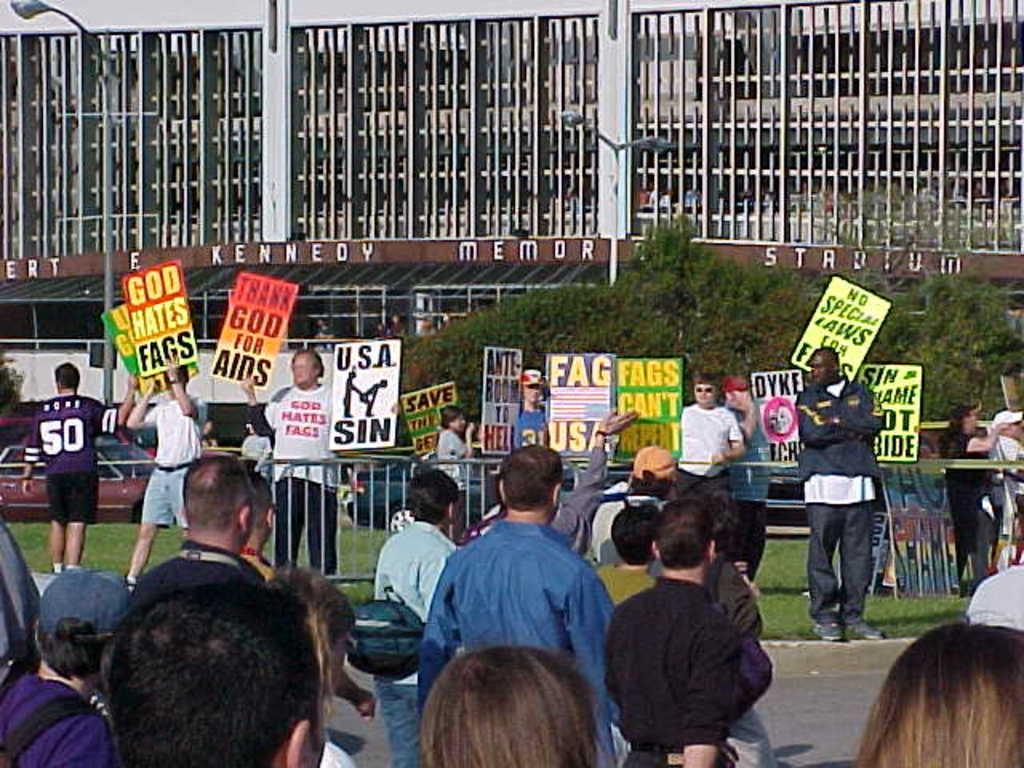What is the main subject of the image? The main subject of the image is a crowd of people. What are the people holding in the image? The people are holding boards with text written on them. What can be seen in the background of the image? There is a stadium in the background of the image. What is visible in the upper part of the image? There are lights visible in the upper part of the image. Can you tell me how many bats are flying around in the image? There are no bats present in the image. What type of structure is the crowd standing on in the image? The provided facts do not mention a specific structure that the crowd is standing on. 